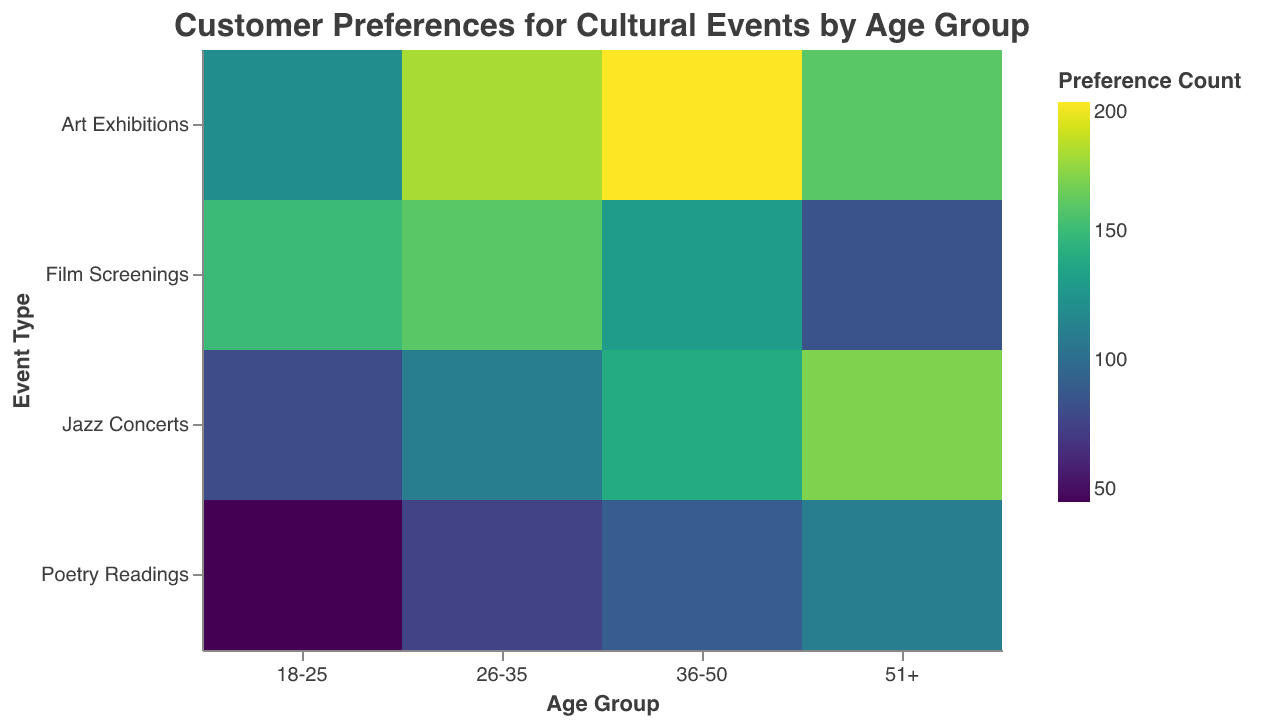What's the title of the plot? The title of the plot is prominently written at the top. It is "Customer Preferences for Cultural Events by Age Group".
Answer: Customer Preferences for Cultural Events by Age Group How many age groups are represented in the plot? By looking at the x-axis, we can count the distinct age group labels. There are "18-25", "26-35", "36-50", and "51+". That's a total of 4 age groups.
Answer: 4 Which age group has the highest preference count for Art Exhibitions? Look for the age group with the darkest color for the 'Art Exhibitions' row, as the color indicates the preference count. The "36-50" age group has the darkest color in this row, indicating the highest count.
Answer: 36-50 What is the preference count for Film Screenings among the 18-25 age group? Locate the intersection of the "18-25" column and "Film Screenings" row. The color represents the preference count, and it is also labeled. The preference count is 150.
Answer: 150 Compare the preference for Jazz Concerts between the 26-35 and 51+ age groups. Which age group shows a higher preference? Compare the color intensities or labeled counts between "26-35" and "51+" in the "Jazz Concerts" row. The 51+ age group shows a count of 170, which is higher than the 110 of the 26-35 age group.
Answer: 51+ Calculate the total preference count for all event types in the 36-50 age group. Add up the counts in the "36-50" column: Art Exhibitions (200), Poetry Readings (90), Jazz Concerts (140), and Film Screenings (130). 200 + 90 + 140 + 130 = 560.
Answer: 560 Which event type has the least preference count among all age groups? Locate the event type that consistently shows lighter colors or lowest counts across age groups. "Poetry Readings" has the consistently lightest shades, indicating lower counts overall.
Answer: Poetry Readings Determine the average preference count for Poetry Readings across all age groups. Sum the counts for Poetry Readings: 45 (18-25), 75 (26-35), 90 (36-50), 110 (51+). Then divide by the number of age groups (4). (45 + 75 + 90 + 110) / 4 = 320 / 4 = 80.
Answer: 80 Which age group has a similar preference count for Art Exhibitions and Jazz Concerts? Compare the counts within each age group. In the "51+" age group, the count for Art Exhibitions is 160 and for Jazz Concerts, it's 170, which are relatively close.
Answer: 51+ 